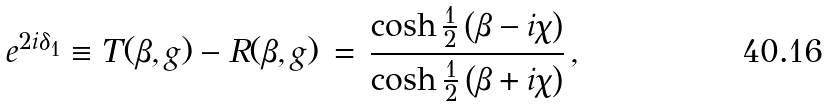Convert formula to latex. <formula><loc_0><loc_0><loc_500><loc_500>e ^ { 2 i \delta _ { 1 } } \equiv T ( \beta , g ) - R ( \beta , g ) \, = \, \frac { \cosh \frac { 1 } { 2 } \left ( \beta - i \chi \right ) } { \cosh \frac { 1 } { 2 } \left ( \beta + i \chi \right ) } \, ,</formula> 